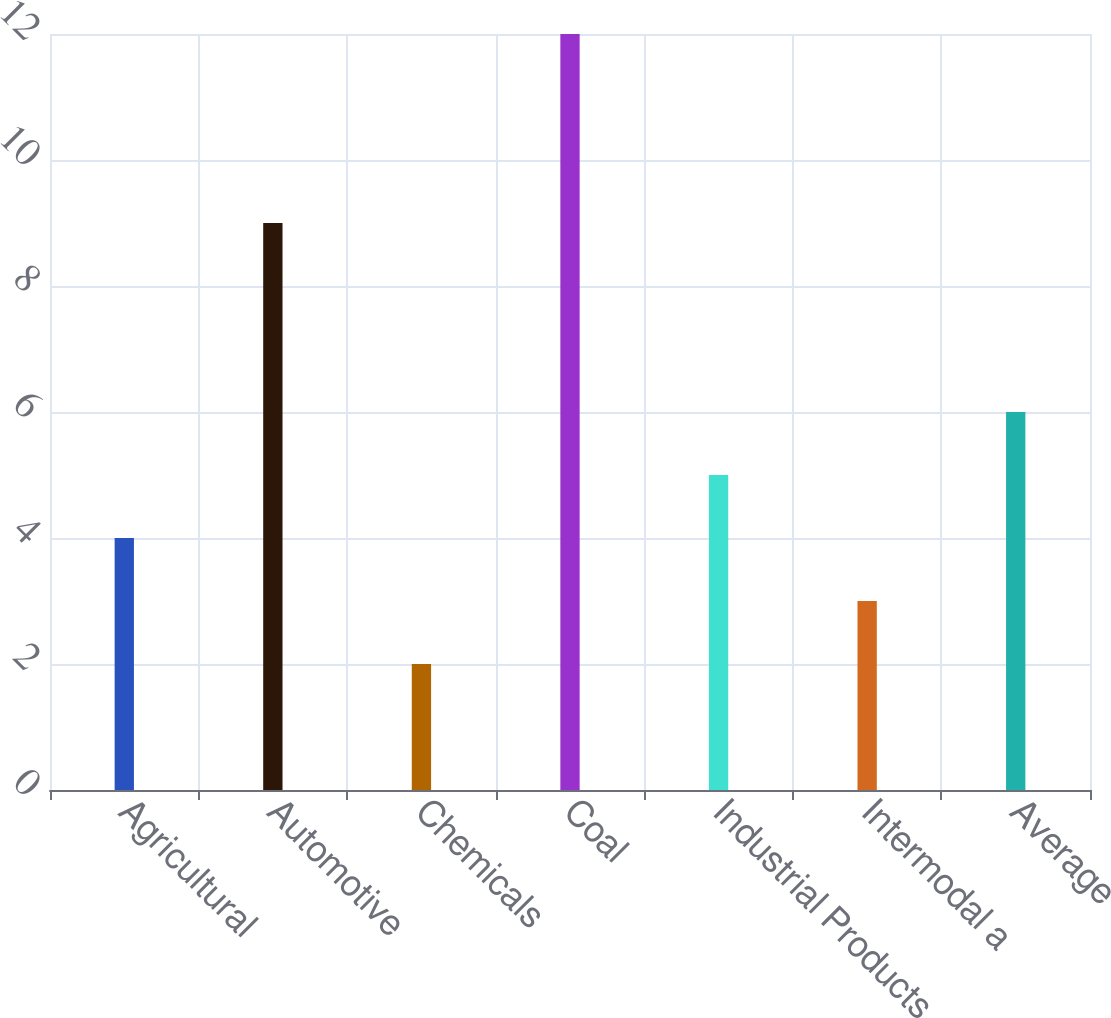Convert chart. <chart><loc_0><loc_0><loc_500><loc_500><bar_chart><fcel>Agricultural<fcel>Automotive<fcel>Chemicals<fcel>Coal<fcel>Industrial Products<fcel>Intermodal a<fcel>Average<nl><fcel>4<fcel>9<fcel>2<fcel>12<fcel>5<fcel>3<fcel>6<nl></chart> 